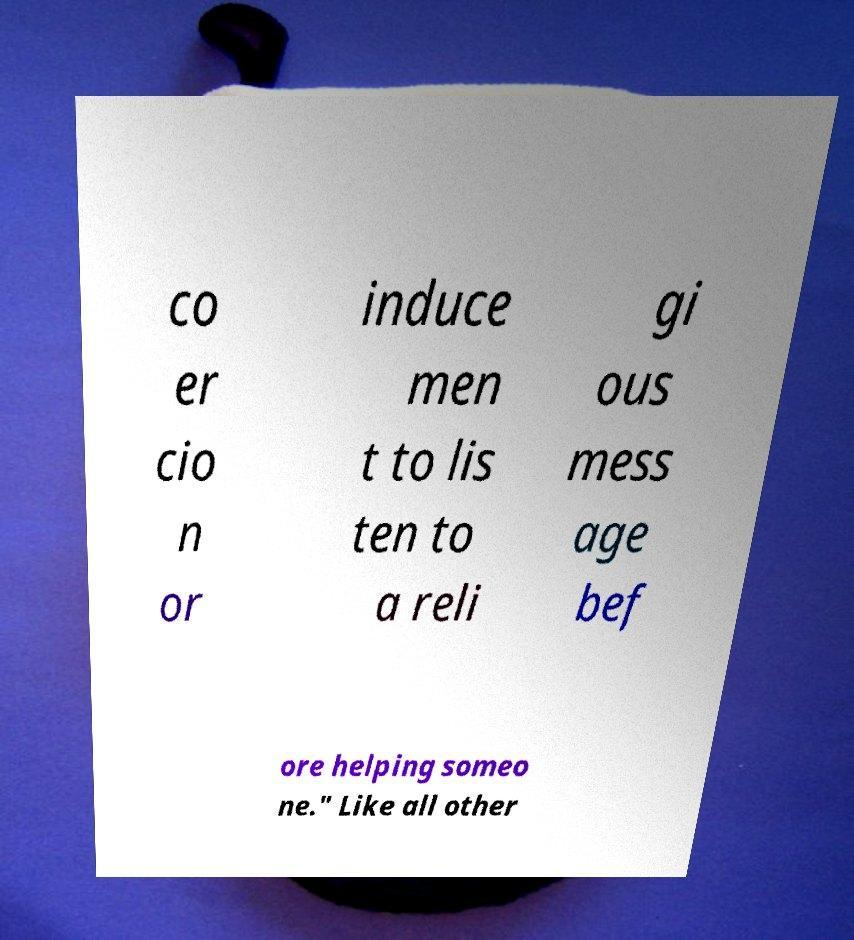Please read and relay the text visible in this image. What does it say? co er cio n or induce men t to lis ten to a reli gi ous mess age bef ore helping someo ne." Like all other 